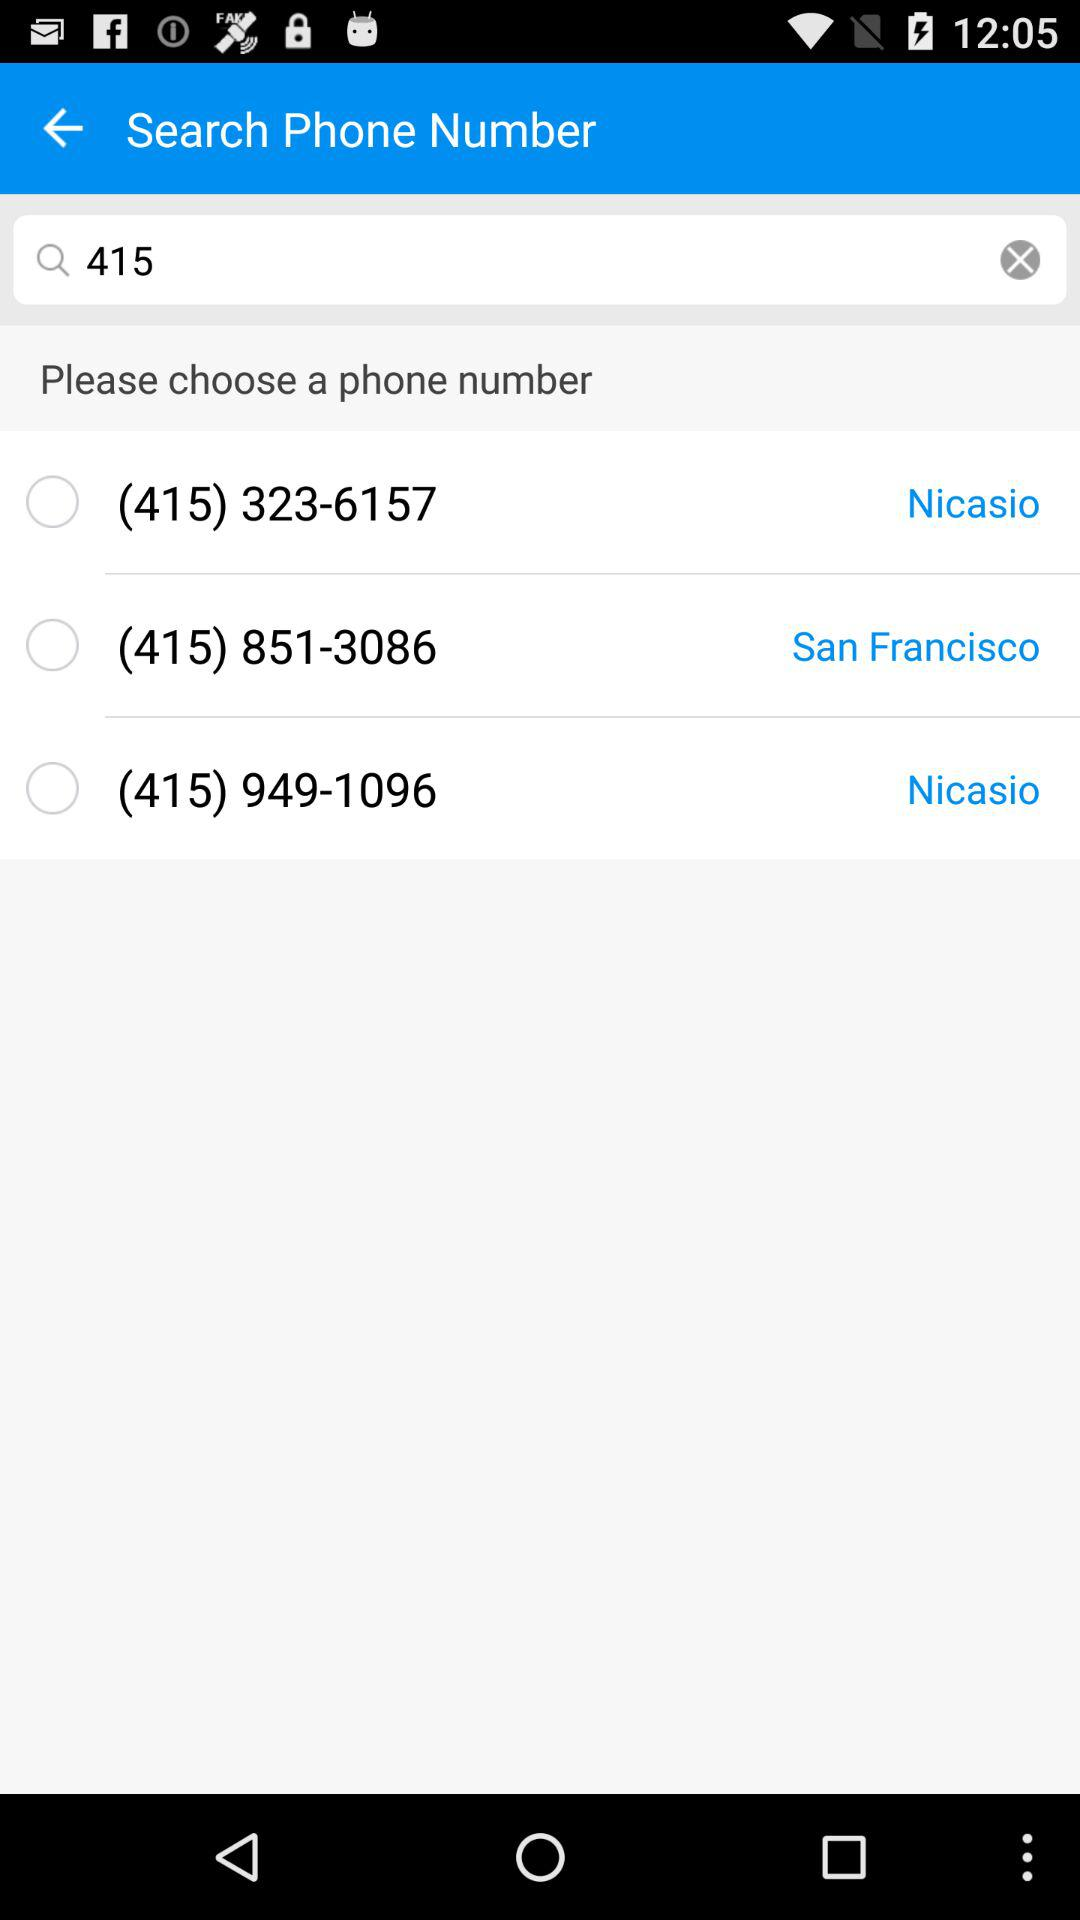What is the phone number for Nicasio? The phone number for Nicasio is (415) 323-6157. 